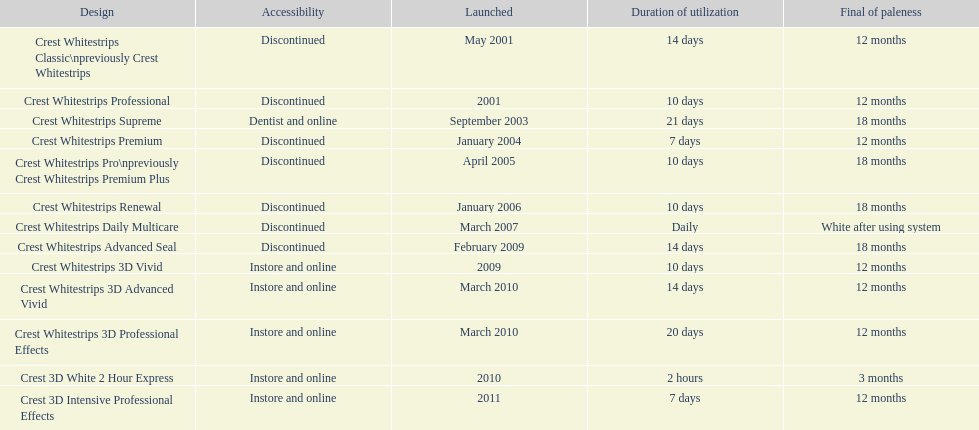How many products have been discontinued? 7. 